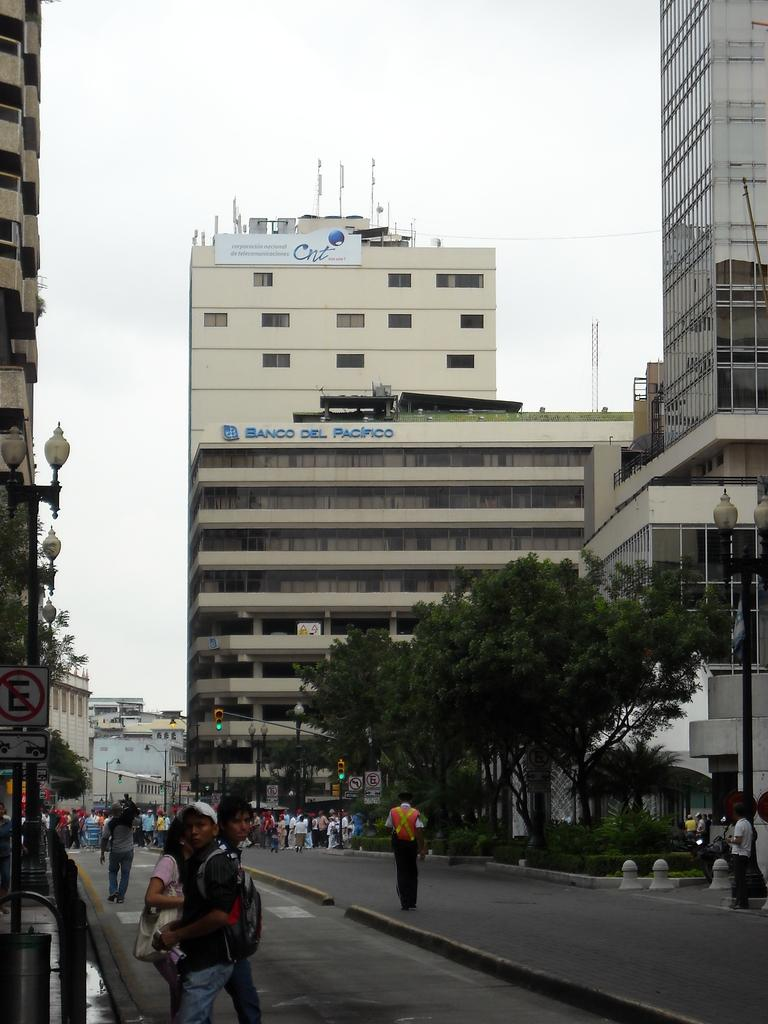Provide a one-sentence caption for the provided image. People mill about on the streets and sidewalk below the Banco Del Pacifio building. 